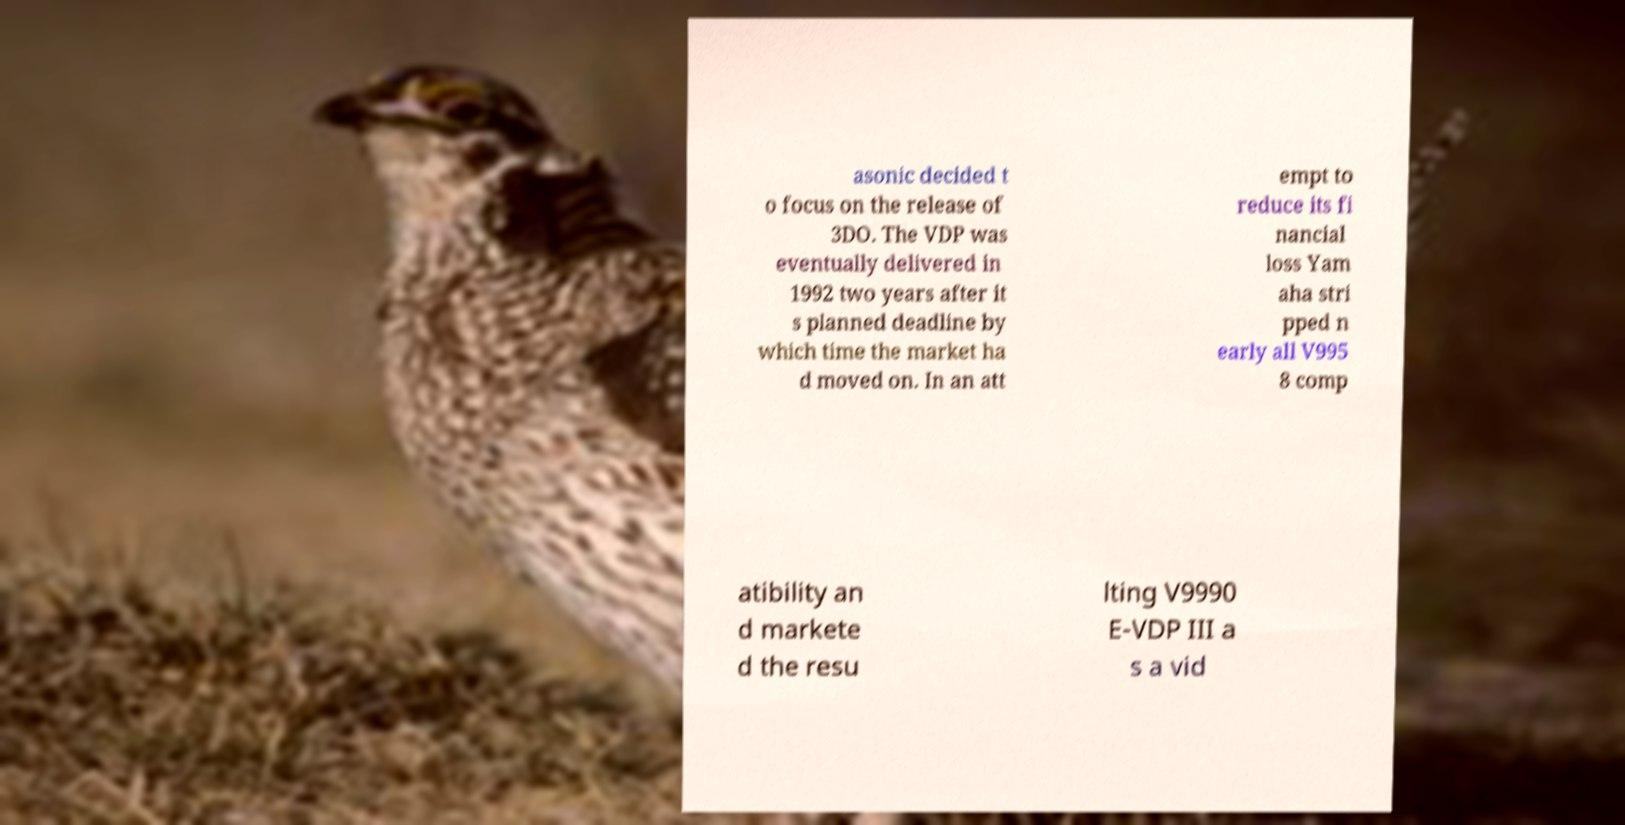Please read and relay the text visible in this image. What does it say? asonic decided t o focus on the release of 3DO. The VDP was eventually delivered in 1992 two years after it s planned deadline by which time the market ha d moved on. In an att empt to reduce its fi nancial loss Yam aha stri pped n early all V995 8 comp atibility an d markete d the resu lting V9990 E-VDP III a s a vid 